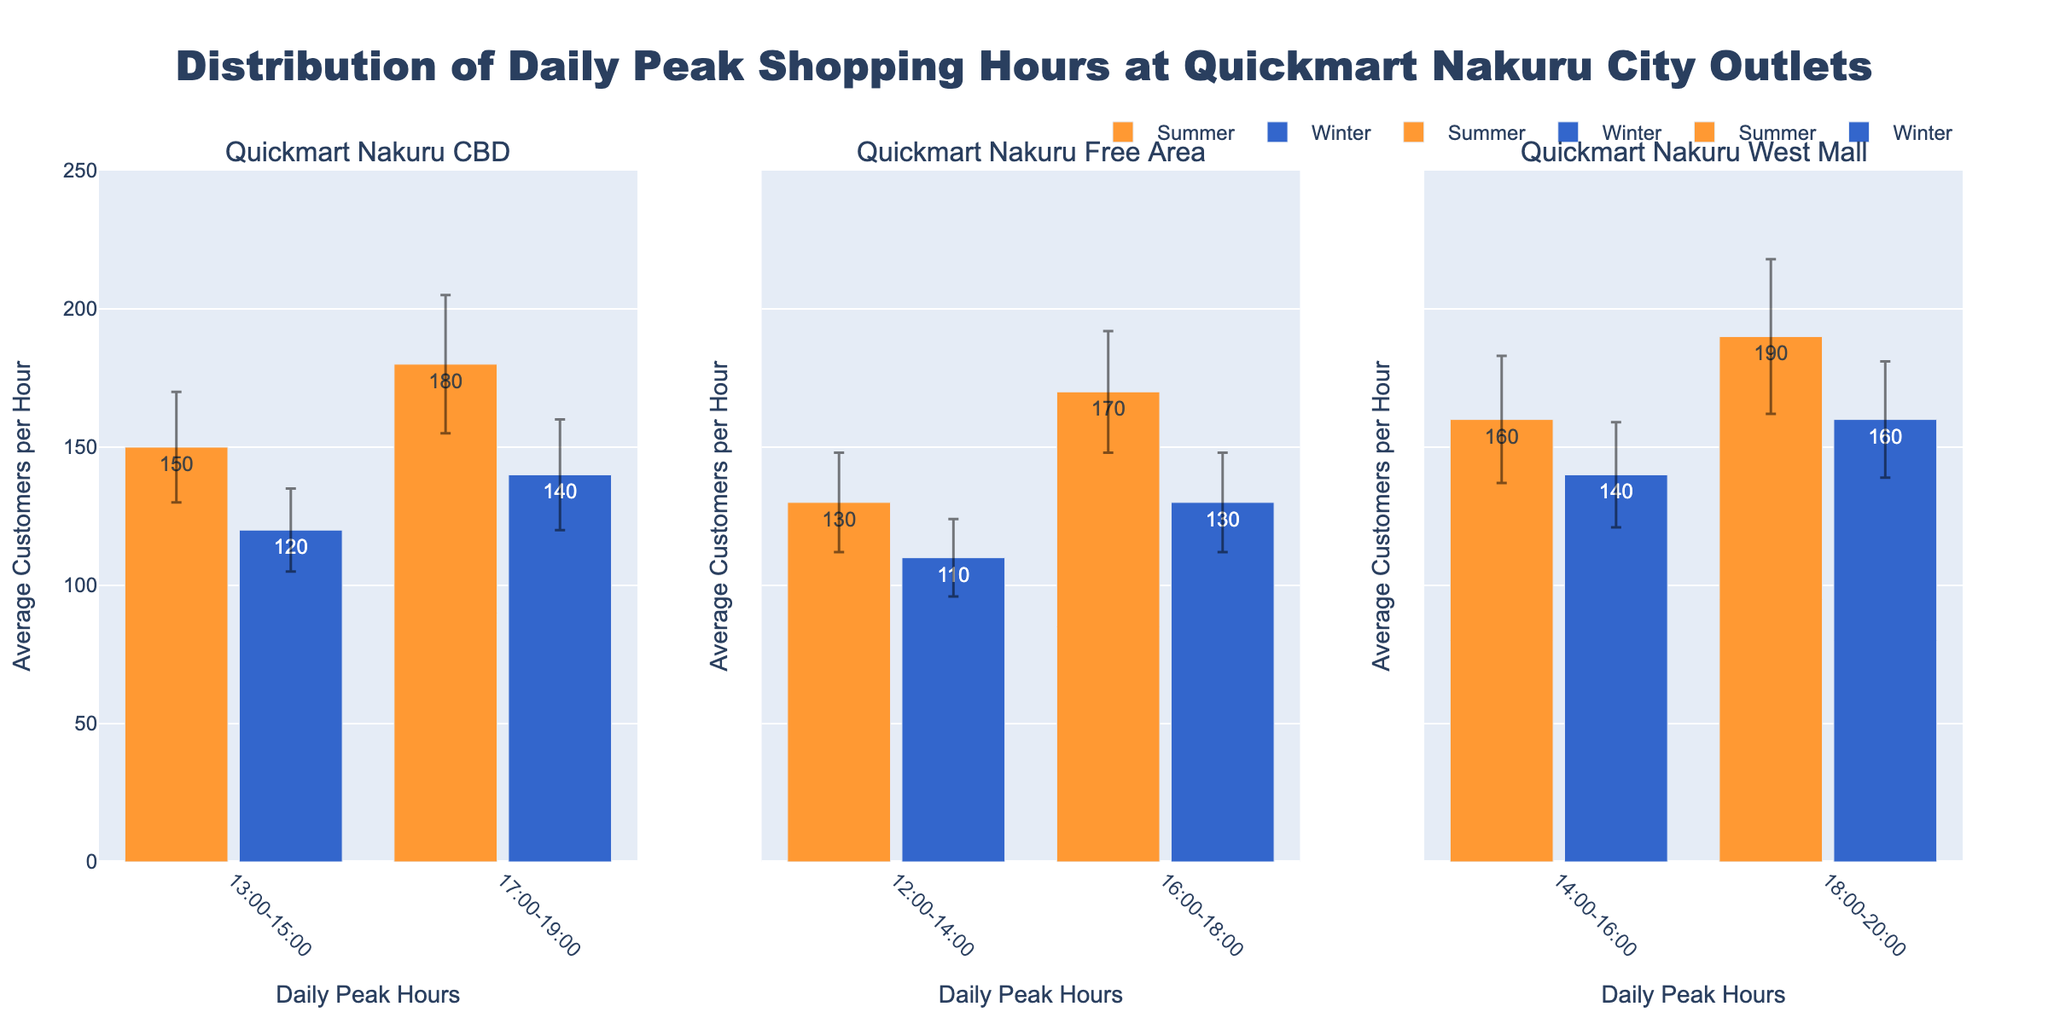What are the daily peak hours during the summer at Quickmart Nakuru CBD? The peak hours during the summer at Quickmart Nakuru CBD are shown directly on the bar chart. Look for the bars on the subplot for Quickmart Nakuru CBD with the summer color.
Answer: 13:00-15:00 and 17:00-19:00 How many average customers shop during 17:00-19:00 in the winter at Quickmart Nakuru CBD? Locate the bar for 17:00-19:00 during the winter season in the Quickmart Nakuru CBD subplot and read the text label on the bar.
Answer: 140 Which season has higher average customer counts during 14:00-16:00 at Quickmart Nakuru West Mall? Compare the heights of the bars for 14:00-16:00 in both summer and winter seasons in the Quickmart Nakuru West Mall subplot.
Answer: Summer What is the standard deviation of the average customers during 12:00-14:00 in the winter at Quickmart Nakuru Free Area? Find the bar for 12:00-14:00 during winter in the Quickmart Nakuru Free Area subplot and check the error bar or the data label.
Answer: 14 Which outlet has the highest average customer count during peak hours in the summer? Compare the heights of all the bars representing peak hours during the summer across all outlets. Look for the highest bar within summer season bars in each subplot.
Answer: Quickmart Nakuru West Mall Which time slot during the summer at Quickmart Nakuru CBD has a larger standard deviation in customer numbers? Compare the error bars of the two summer time slots in the Quickmart Nakuru CBD subplot. The longer error bar indicates a larger standard deviation.
Answer: 17:00-19:00 Between Quickmart Nakuru CBD and Quickmart Nakuru Free Area, which outlet has a higher peak customer count during winter afternoons? Compare the heights of the bars representing winter afternoons (either 12:00-14:00 or 13:00-15:00) for the two outlets.
Answer: Quickmart Nakuru CBD 